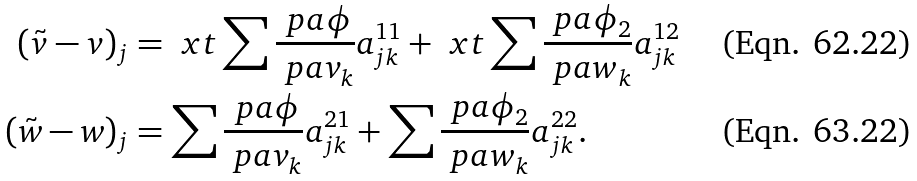Convert formula to latex. <formula><loc_0><loc_0><loc_500><loc_500>( \tilde { v } - v ) _ { j } & = \ x t \sum \frac { \ p a \phi } { \ p a v _ { k } } a ^ { 1 1 } _ { j k } + \ x t \sum \frac { \ p a \phi _ { 2 } } { \ p a w _ { k } } a ^ { 1 2 } _ { j k } \\ ( \tilde { w } - w ) _ { j } & = \sum \frac { \ p a \phi } { \ p a v _ { k } } a ^ { 2 1 } _ { j k } + \sum \frac { \ p a \phi _ { 2 } } { \ p a w _ { k } } a ^ { 2 2 } _ { j k } .</formula> 